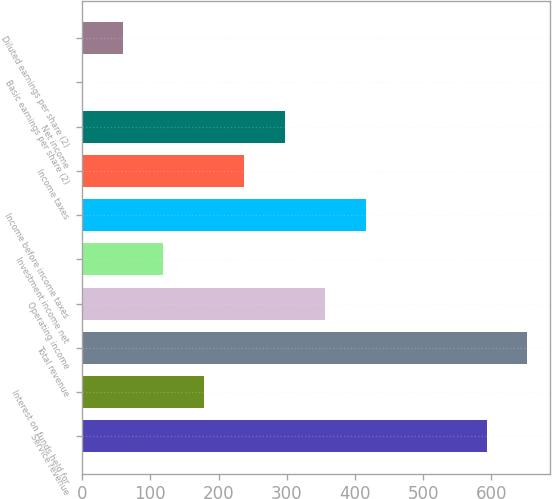Convert chart. <chart><loc_0><loc_0><loc_500><loc_500><bar_chart><fcel>Service revenue<fcel>Interest on funds held for<fcel>Total revenue<fcel>Operating income<fcel>Investment income net<fcel>Income before income taxes<fcel>Income taxes<fcel>Net income<fcel>Basic earnings per share (2)<fcel>Diluted earnings per share (2)<nl><fcel>593.3<fcel>178.27<fcel>652.59<fcel>356.14<fcel>118.98<fcel>415.43<fcel>237.56<fcel>296.85<fcel>0.4<fcel>59.69<nl></chart> 